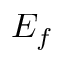Convert formula to latex. <formula><loc_0><loc_0><loc_500><loc_500>E _ { f }</formula> 